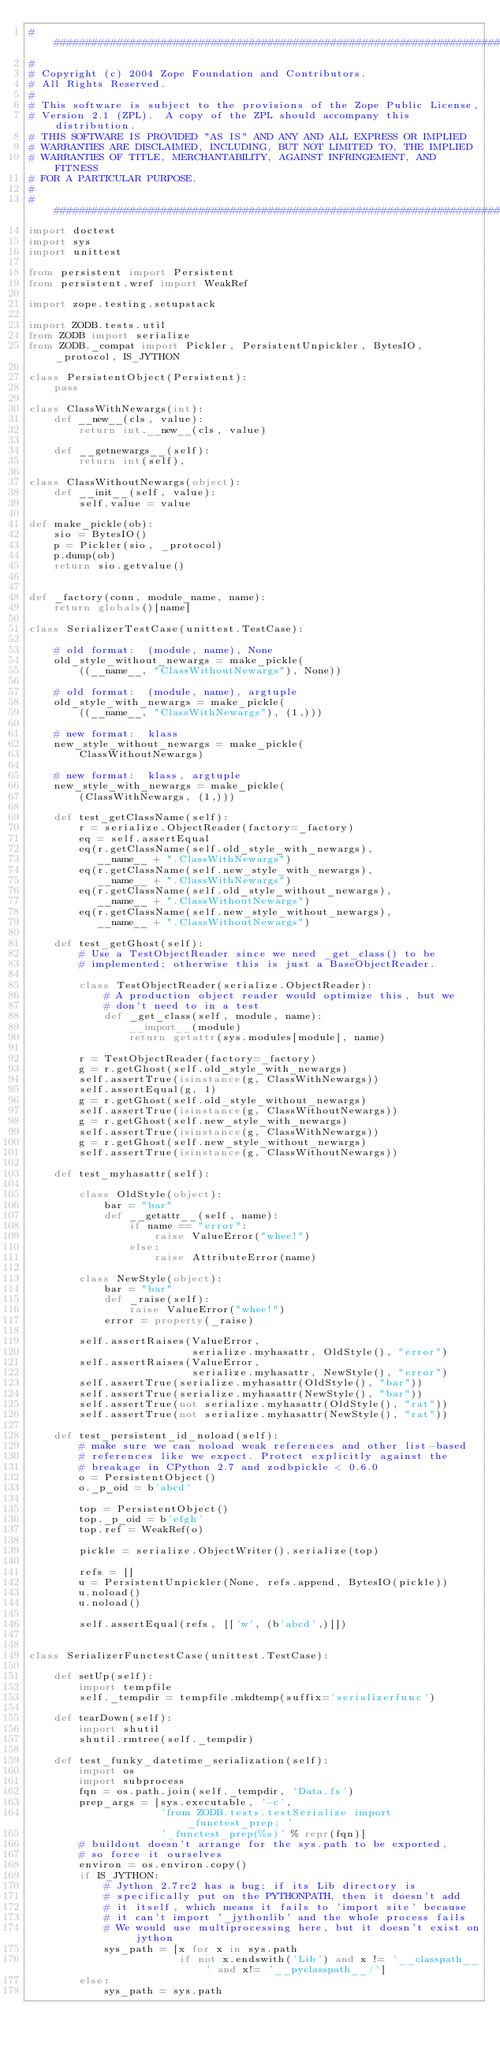Convert code to text. <code><loc_0><loc_0><loc_500><loc_500><_Python_>##############################################################################
#
# Copyright (c) 2004 Zope Foundation and Contributors.
# All Rights Reserved.
#
# This software is subject to the provisions of the Zope Public License,
# Version 2.1 (ZPL).  A copy of the ZPL should accompany this distribution.
# THIS SOFTWARE IS PROVIDED "AS IS" AND ANY AND ALL EXPRESS OR IMPLIED
# WARRANTIES ARE DISCLAIMED, INCLUDING, BUT NOT LIMITED TO, THE IMPLIED
# WARRANTIES OF TITLE, MERCHANTABILITY, AGAINST INFRINGEMENT, AND FITNESS
# FOR A PARTICULAR PURPOSE.
#
##############################################################################
import doctest
import sys
import unittest

from persistent import Persistent
from persistent.wref import WeakRef

import zope.testing.setupstack

import ZODB.tests.util
from ZODB import serialize
from ZODB._compat import Pickler, PersistentUnpickler, BytesIO, _protocol, IS_JYTHON

class PersistentObject(Persistent):
    pass

class ClassWithNewargs(int):
    def __new__(cls, value):
        return int.__new__(cls, value)

    def __getnewargs__(self):
        return int(self),

class ClassWithoutNewargs(object):
    def __init__(self, value):
        self.value = value

def make_pickle(ob):
    sio = BytesIO()
    p = Pickler(sio, _protocol)
    p.dump(ob)
    return sio.getvalue()


def _factory(conn, module_name, name):
    return globals()[name]

class SerializerTestCase(unittest.TestCase):

    # old format:  (module, name), None
    old_style_without_newargs = make_pickle(
        ((__name__, "ClassWithoutNewargs"), None))

    # old format:  (module, name), argtuple
    old_style_with_newargs = make_pickle(
        ((__name__, "ClassWithNewargs"), (1,)))

    # new format:  klass
    new_style_without_newargs = make_pickle(
        ClassWithoutNewargs)

    # new format:  klass, argtuple
    new_style_with_newargs = make_pickle(
        (ClassWithNewargs, (1,)))

    def test_getClassName(self):
        r = serialize.ObjectReader(factory=_factory)
        eq = self.assertEqual
        eq(r.getClassName(self.old_style_with_newargs),
           __name__ + ".ClassWithNewargs")
        eq(r.getClassName(self.new_style_with_newargs),
           __name__ + ".ClassWithNewargs")
        eq(r.getClassName(self.old_style_without_newargs),
           __name__ + ".ClassWithoutNewargs")
        eq(r.getClassName(self.new_style_without_newargs),
           __name__ + ".ClassWithoutNewargs")

    def test_getGhost(self):
        # Use a TestObjectReader since we need _get_class() to be
        # implemented; otherwise this is just a BaseObjectReader.

        class TestObjectReader(serialize.ObjectReader):
            # A production object reader would optimize this, but we
            # don't need to in a test
            def _get_class(self, module, name):
                __import__(module)
                return getattr(sys.modules[module], name)

        r = TestObjectReader(factory=_factory)
        g = r.getGhost(self.old_style_with_newargs)
        self.assertTrue(isinstance(g, ClassWithNewargs))
        self.assertEqual(g, 1)
        g = r.getGhost(self.old_style_without_newargs)
        self.assertTrue(isinstance(g, ClassWithoutNewargs))
        g = r.getGhost(self.new_style_with_newargs)
        self.assertTrue(isinstance(g, ClassWithNewargs))
        g = r.getGhost(self.new_style_without_newargs)
        self.assertTrue(isinstance(g, ClassWithoutNewargs))

    def test_myhasattr(self):

        class OldStyle(object):
            bar = "bar"
            def __getattr__(self, name):
                if name == "error":
                    raise ValueError("whee!")
                else:
                    raise AttributeError(name)

        class NewStyle(object):
            bar = "bar"
            def _raise(self):
                raise ValueError("whee!")
            error = property(_raise)

        self.assertRaises(ValueError,
                          serialize.myhasattr, OldStyle(), "error")
        self.assertRaises(ValueError,
                          serialize.myhasattr, NewStyle(), "error")
        self.assertTrue(serialize.myhasattr(OldStyle(), "bar"))
        self.assertTrue(serialize.myhasattr(NewStyle(), "bar"))
        self.assertTrue(not serialize.myhasattr(OldStyle(), "rat"))
        self.assertTrue(not serialize.myhasattr(NewStyle(), "rat"))

    def test_persistent_id_noload(self):
        # make sure we can noload weak references and other list-based
        # references like we expect. Protect explicitly against the
        # breakage in CPython 2.7 and zodbpickle < 0.6.0
        o = PersistentObject()
        o._p_oid = b'abcd'

        top = PersistentObject()
        top._p_oid = b'efgh'
        top.ref = WeakRef(o)

        pickle = serialize.ObjectWriter().serialize(top)

        refs = []
        u = PersistentUnpickler(None, refs.append, BytesIO(pickle))
        u.noload()
        u.noload()

        self.assertEqual(refs, [['w', (b'abcd',)]])


class SerializerFunctestCase(unittest.TestCase):

    def setUp(self):
        import tempfile
        self._tempdir = tempfile.mkdtemp(suffix='serializerfunc')

    def tearDown(self):
        import shutil
        shutil.rmtree(self._tempdir)

    def test_funky_datetime_serialization(self):
        import os
        import subprocess
        fqn = os.path.join(self._tempdir, 'Data.fs')
        prep_args = [sys.executable, '-c',
                     'from ZODB.tests.testSerialize import _functest_prep; '
                     '_functest_prep(%s)' % repr(fqn)]
        # buildout doesn't arrange for the sys.path to be exported,
        # so force it ourselves
        environ = os.environ.copy()
        if IS_JYTHON:
            # Jython 2.7rc2 has a bug; if its Lib directory is
            # specifically put on the PYTHONPATH, then it doesn't add
            # it itself, which means it fails to 'import site' because
            # it can't import '_jythonlib' and the whole process fails
            # We would use multiprocessing here, but it doesn't exist on jython
            sys_path = [x for x in sys.path
                        if not x.endswith('Lib') and x != '__classpath__' and x!= '__pyclasspath__/']
        else:
            sys_path = sys.path</code> 